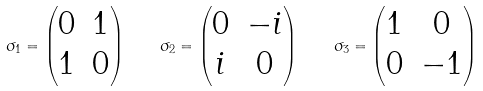Convert formula to latex. <formula><loc_0><loc_0><loc_500><loc_500>\sigma _ { 1 } = \left ( \begin{matrix} 0 & 1 \\ 1 & 0 \\ \end{matrix} \right ) \quad \sigma _ { 2 } = \left ( \begin{matrix} 0 & - i \\ i & 0 \\ \end{matrix} \right ) \quad \sigma _ { 3 } = \left ( \begin{matrix} 1 & 0 \\ 0 & - 1 \\ \end{matrix} \right )</formula> 